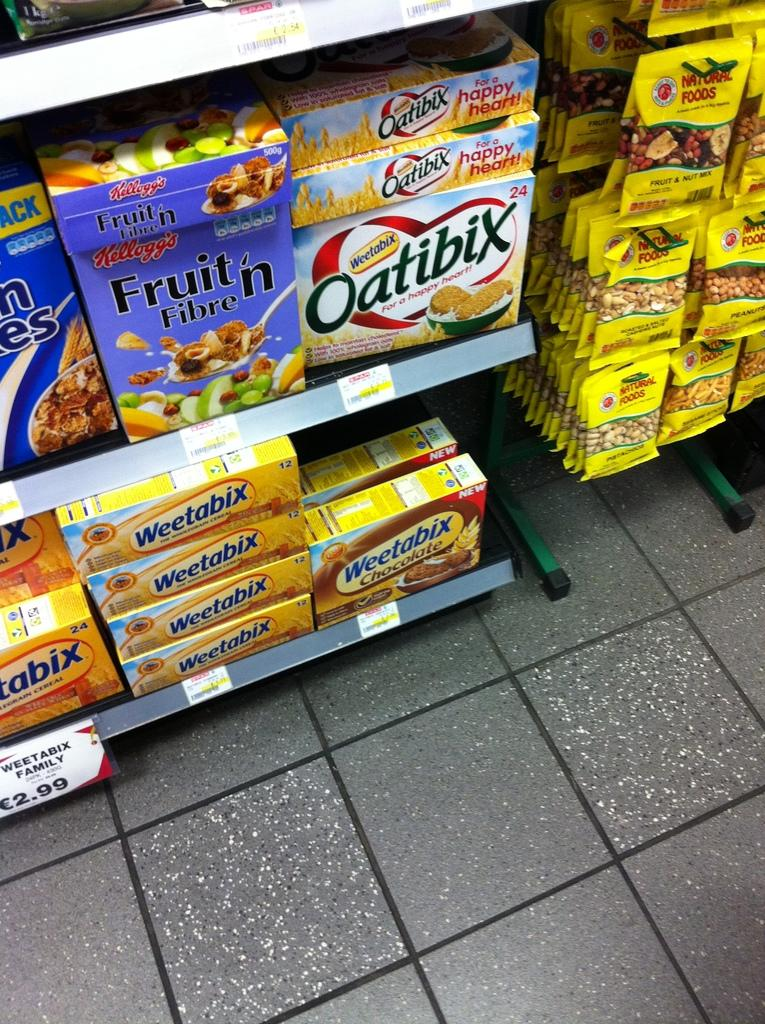<image>
Create a compact narrative representing the image presented. A box of Oatibix sits on a grocery store shelf next to some cereal. 